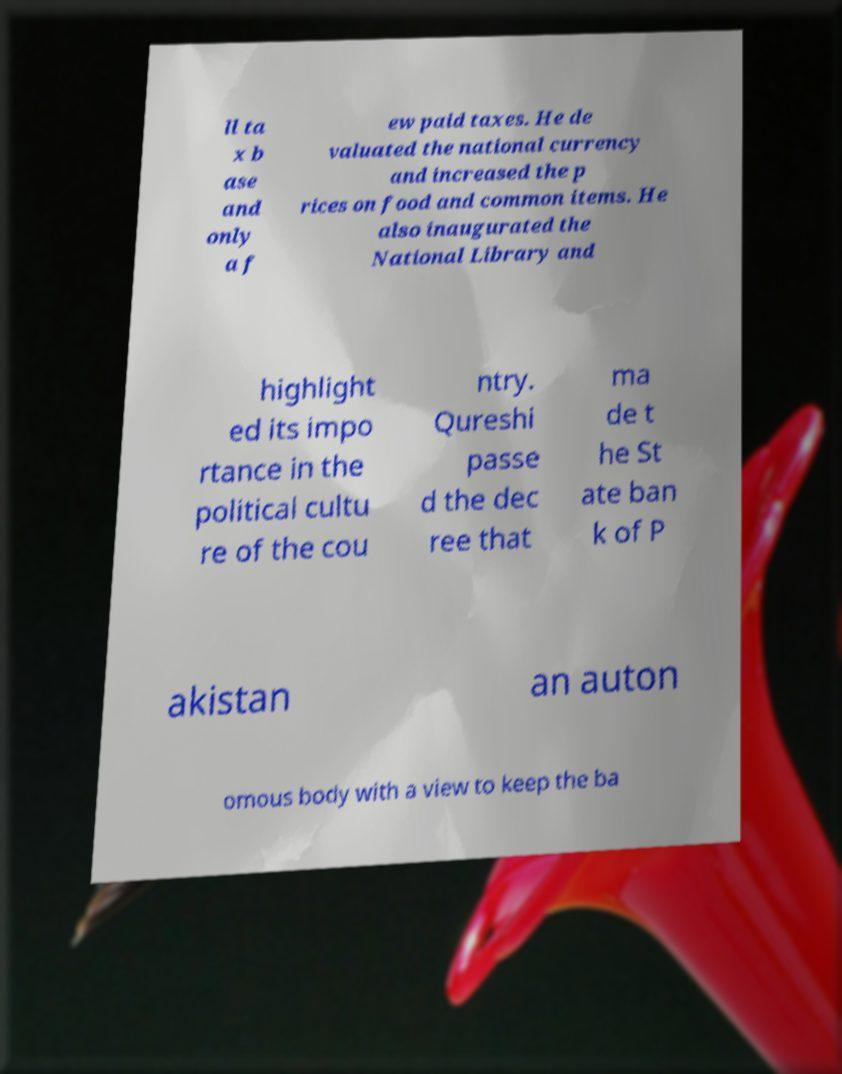What messages or text are displayed in this image? I need them in a readable, typed format. ll ta x b ase and only a f ew paid taxes. He de valuated the national currency and increased the p rices on food and common items. He also inaugurated the National Library and highlight ed its impo rtance in the political cultu re of the cou ntry. Qureshi passe d the dec ree that ma de t he St ate ban k of P akistan an auton omous body with a view to keep the ba 